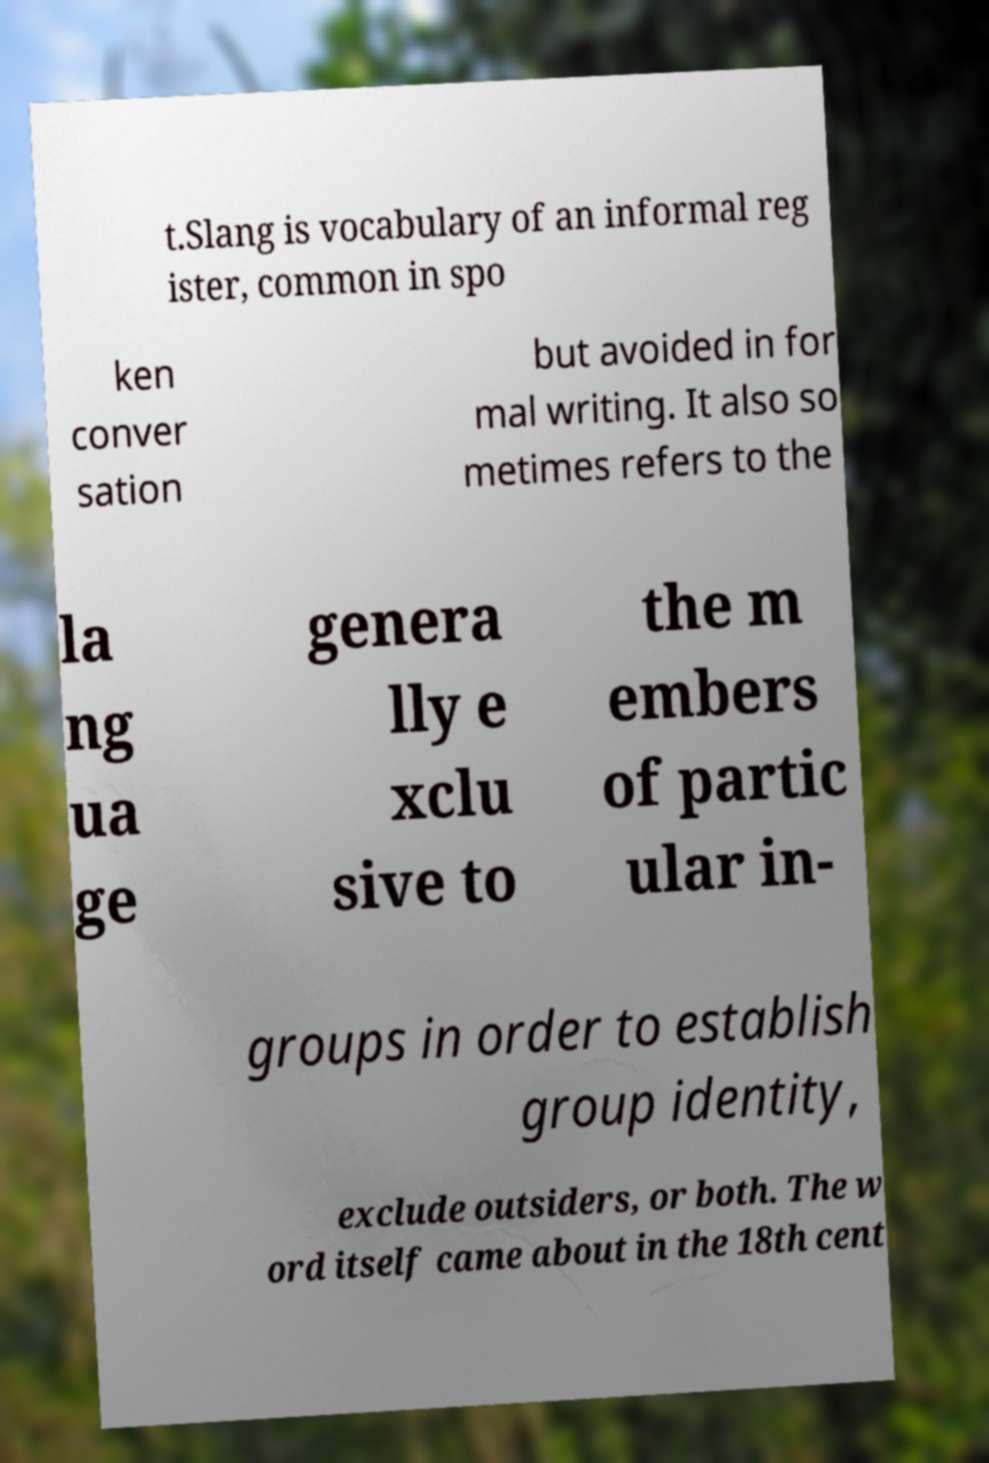Please identify and transcribe the text found in this image. t.Slang is vocabulary of an informal reg ister, common in spo ken conver sation but avoided in for mal writing. It also so metimes refers to the la ng ua ge genera lly e xclu sive to the m embers of partic ular in- groups in order to establish group identity, exclude outsiders, or both. The w ord itself came about in the 18th cent 